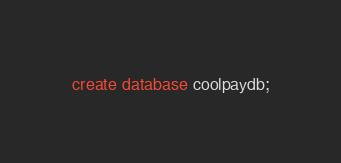<code> <loc_0><loc_0><loc_500><loc_500><_SQL_>create database coolpaydb;
</code> 